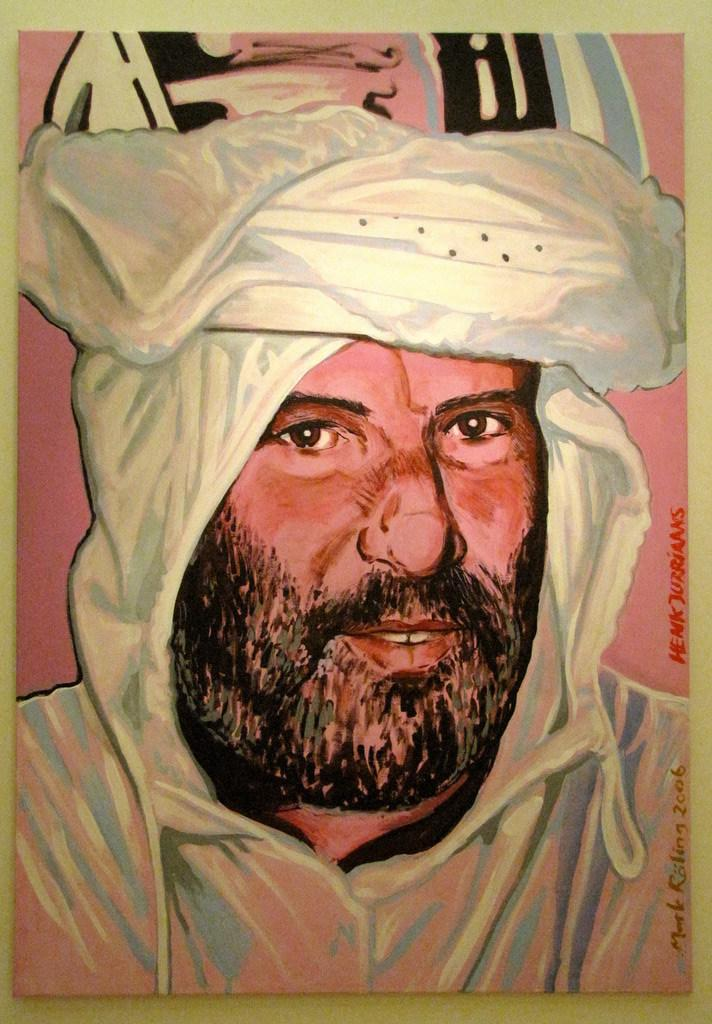What is located in the foreground of the image? There is a frame in the foreground of the image. What is inside the frame? The frame contains a painting. What is the subject of the painting? The painting depicts a man. What is the background color of the painting? The painting is on a white surface. What type of tree can be seen in the painting? There is no tree present in the painting; it depicts a man. What role does the actor play in the image? There is no actor present in the image; it features a painting of a man. 